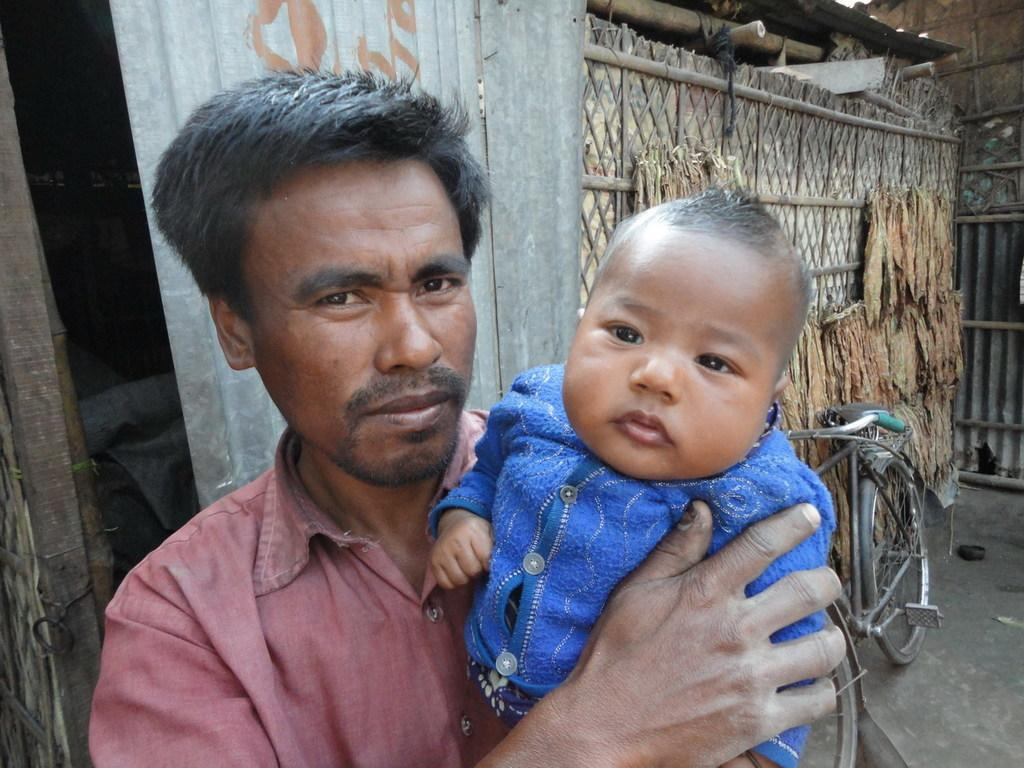What is the man in the image holding? The man is holding a baby in the image. What type of material is visible in the image? There are metal sheets visible in the image. What mode of transportation can be seen in the image? There is a bicycle in the image. What type of structures are present in the image? There are huts in the image. Can you describe any other objects in the image? There are objects in the image, but their specific nature is not mentioned in the provided facts. What type of cheese is being grated on the baby's nose in the image? There is no cheese or nose-grating activity present in the image. Is there a bed visible in the image? There is no mention of a bed in the provided facts, so it cannot be determined if one is present in the image. 